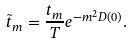Convert formula to latex. <formula><loc_0><loc_0><loc_500><loc_500>\tilde { t } _ { m } = \frac { t _ { m } } { T } e ^ { - m ^ { 2 } D ( 0 ) } .</formula> 